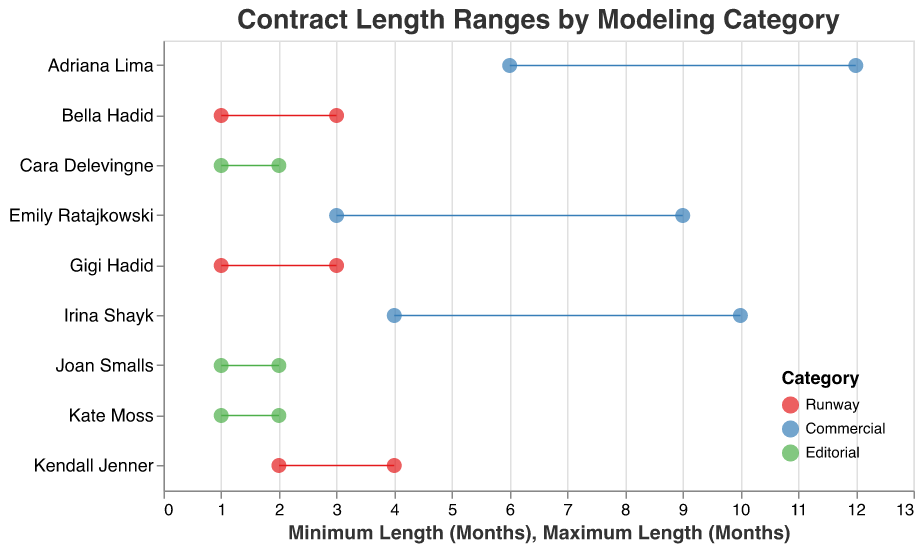What's the title of the figure? The title is displayed at the top of the figure in the center. It reads "Contract Length Ranges by Modeling Category".
Answer: Contract Length Ranges by Modeling Category Which model has the longest maximum contract length? The maximum contract lengths are represented by the rightmost points on each line. Adriana Lima from the Commercial category has the longest maximum contract length at 12 months.
Answer: Adriana Lima What are the minimum and maximum contract lengths for Kendall Jenner? Kendall Jenner's data is shown in the Runway section. The line representing her contract length ranges from 2 months (minimum) to 4 months (maximum).
Answer: 2 to 4 months Which category has the smallest range of contract lengths? The Editorial category has the smallest ranges, as all models (Cara Delevingne, Joan Smalls, and Kate Moss) have contract lengths ranging from 1 to 2 months.
Answer: Editorial What is the average maximum contract length for models in the Commercial category? The Commercial category's maximum lengths are 12 (Adriana Lima), 9 (Emily Ratajkowski), and 10 (Irina Shayk). Calculate the average: (12 + 9 + 10) / 3 = 31 / 3 = 10.33
Answer: 10.33 Compare the contract ranges of Bella Hadid and Gigi Hadid. Which one has a longer maximum contract length? Both Bella Hadid and Gigi Hadid are in the Runway category. Bella Hadid's contract ranges from 1 to 3 months, while Gigi Hadid's also ranges from 1 to 3 months. Their maximum contract lengths are the same.
Answer: Equal How many models have a minimum contract length of 1 month? Models with a minimum contract length of 1 month can be seen in the Ranged Dot Plot. They include Bella Hadid, Gigi Hadid, Cara Delevingne, Joan Smalls, and Kate Moss. Count the models listed: 5 models.
Answer: 5 models Which model has the widest range in contract length within the Editorial category? In the Editorial category, all models (Cara Delevingne, Joan Smalls, and Kate Moss) have a contract length ranging from 1 to 2 months. They all have the same range of 1 month (2 - 1 = 1 month).
Answer: All have equal (1 month) How does the minimum contract length for Irina Shayk compare to that for Emily Ratajkowski? Both models are in the Commercial category. Irina Shayk's minimum contract length is 4 months, whereas Emily Ratajkowski's is 3 months. Irina Shayk's minimum contract length is longer.
Answer: Irina Shayk's is longer Which category has the highest average maximum contract length, and what is it? Calculate the average maximum contract length for each category: 
Runway: (3 + 4 + 3) / 3 = 10 / 3 = 3.33 
Commercial: (12 + 9 + 10) / 3 = 31 / 3 = 10.33 
Editorial: (2 + 2 + 2) / 3 = 6 / 3 = 2 
The Commercial category has the highest average maximum contract length.
Answer: Commercial, 10.33 